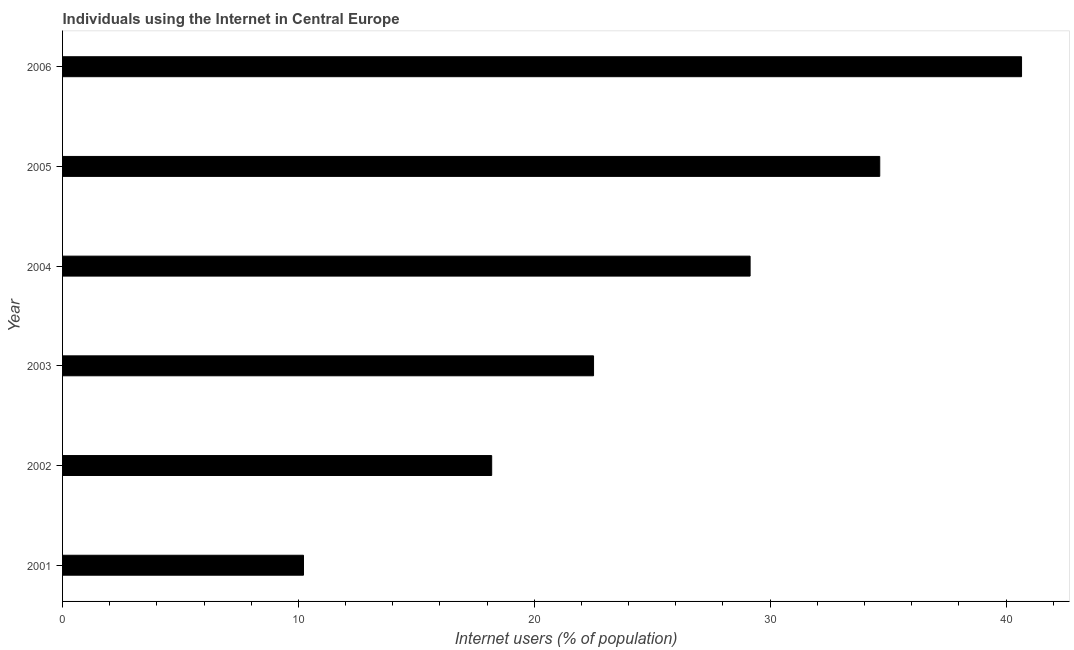Does the graph contain any zero values?
Your answer should be compact. No. What is the title of the graph?
Offer a terse response. Individuals using the Internet in Central Europe. What is the label or title of the X-axis?
Your response must be concise. Internet users (% of population). What is the label or title of the Y-axis?
Make the answer very short. Year. What is the number of internet users in 2002?
Provide a succinct answer. 18.19. Across all years, what is the maximum number of internet users?
Give a very brief answer. 40.66. Across all years, what is the minimum number of internet users?
Your answer should be compact. 10.22. What is the sum of the number of internet users?
Offer a terse response. 155.38. What is the difference between the number of internet users in 2002 and 2004?
Ensure brevity in your answer.  -10.96. What is the average number of internet users per year?
Ensure brevity in your answer.  25.9. What is the median number of internet users?
Offer a very short reply. 25.83. In how many years, is the number of internet users greater than 40 %?
Keep it short and to the point. 1. What is the ratio of the number of internet users in 2003 to that in 2005?
Provide a succinct answer. 0.65. Is the number of internet users in 2001 less than that in 2003?
Your answer should be very brief. Yes. What is the difference between the highest and the second highest number of internet users?
Offer a terse response. 6.01. What is the difference between the highest and the lowest number of internet users?
Make the answer very short. 30.44. Are the values on the major ticks of X-axis written in scientific E-notation?
Offer a very short reply. No. What is the Internet users (% of population) of 2001?
Make the answer very short. 10.22. What is the Internet users (% of population) in 2002?
Offer a very short reply. 18.19. What is the Internet users (% of population) of 2003?
Keep it short and to the point. 22.51. What is the Internet users (% of population) in 2004?
Offer a very short reply. 29.15. What is the Internet users (% of population) of 2005?
Offer a terse response. 34.65. What is the Internet users (% of population) of 2006?
Make the answer very short. 40.66. What is the difference between the Internet users (% of population) in 2001 and 2002?
Your answer should be compact. -7.98. What is the difference between the Internet users (% of population) in 2001 and 2003?
Make the answer very short. -12.3. What is the difference between the Internet users (% of population) in 2001 and 2004?
Provide a succinct answer. -18.94. What is the difference between the Internet users (% of population) in 2001 and 2005?
Your answer should be compact. -24.43. What is the difference between the Internet users (% of population) in 2001 and 2006?
Make the answer very short. -30.44. What is the difference between the Internet users (% of population) in 2002 and 2003?
Your answer should be very brief. -4.32. What is the difference between the Internet users (% of population) in 2002 and 2004?
Keep it short and to the point. -10.96. What is the difference between the Internet users (% of population) in 2002 and 2005?
Offer a very short reply. -16.45. What is the difference between the Internet users (% of population) in 2002 and 2006?
Provide a short and direct response. -22.46. What is the difference between the Internet users (% of population) in 2003 and 2004?
Give a very brief answer. -6.64. What is the difference between the Internet users (% of population) in 2003 and 2005?
Offer a terse response. -12.13. What is the difference between the Internet users (% of population) in 2003 and 2006?
Offer a terse response. -18.15. What is the difference between the Internet users (% of population) in 2004 and 2005?
Offer a very short reply. -5.5. What is the difference between the Internet users (% of population) in 2004 and 2006?
Provide a short and direct response. -11.51. What is the difference between the Internet users (% of population) in 2005 and 2006?
Provide a succinct answer. -6.01. What is the ratio of the Internet users (% of population) in 2001 to that in 2002?
Make the answer very short. 0.56. What is the ratio of the Internet users (% of population) in 2001 to that in 2003?
Your answer should be very brief. 0.45. What is the ratio of the Internet users (% of population) in 2001 to that in 2005?
Offer a very short reply. 0.29. What is the ratio of the Internet users (% of population) in 2001 to that in 2006?
Give a very brief answer. 0.25. What is the ratio of the Internet users (% of population) in 2002 to that in 2003?
Ensure brevity in your answer.  0.81. What is the ratio of the Internet users (% of population) in 2002 to that in 2004?
Provide a succinct answer. 0.62. What is the ratio of the Internet users (% of population) in 2002 to that in 2005?
Make the answer very short. 0.53. What is the ratio of the Internet users (% of population) in 2002 to that in 2006?
Keep it short and to the point. 0.45. What is the ratio of the Internet users (% of population) in 2003 to that in 2004?
Provide a succinct answer. 0.77. What is the ratio of the Internet users (% of population) in 2003 to that in 2005?
Your answer should be very brief. 0.65. What is the ratio of the Internet users (% of population) in 2003 to that in 2006?
Provide a short and direct response. 0.55. What is the ratio of the Internet users (% of population) in 2004 to that in 2005?
Provide a succinct answer. 0.84. What is the ratio of the Internet users (% of population) in 2004 to that in 2006?
Provide a short and direct response. 0.72. What is the ratio of the Internet users (% of population) in 2005 to that in 2006?
Provide a succinct answer. 0.85. 